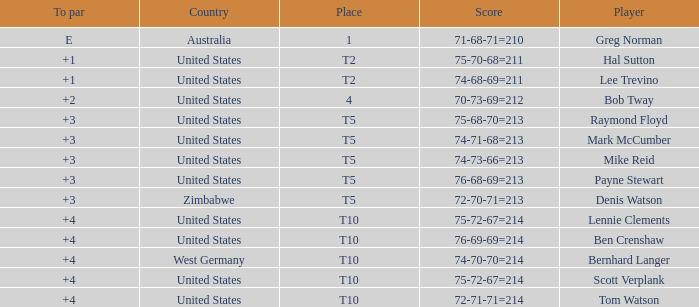Who is the participant with a +3 to par and a 74-71-68=213 score? Mark McCumber. 